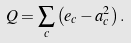Convert formula to latex. <formula><loc_0><loc_0><loc_500><loc_500>Q = \sum _ { c } \left ( e _ { c } - a _ { c } ^ { 2 } \right ) .</formula> 